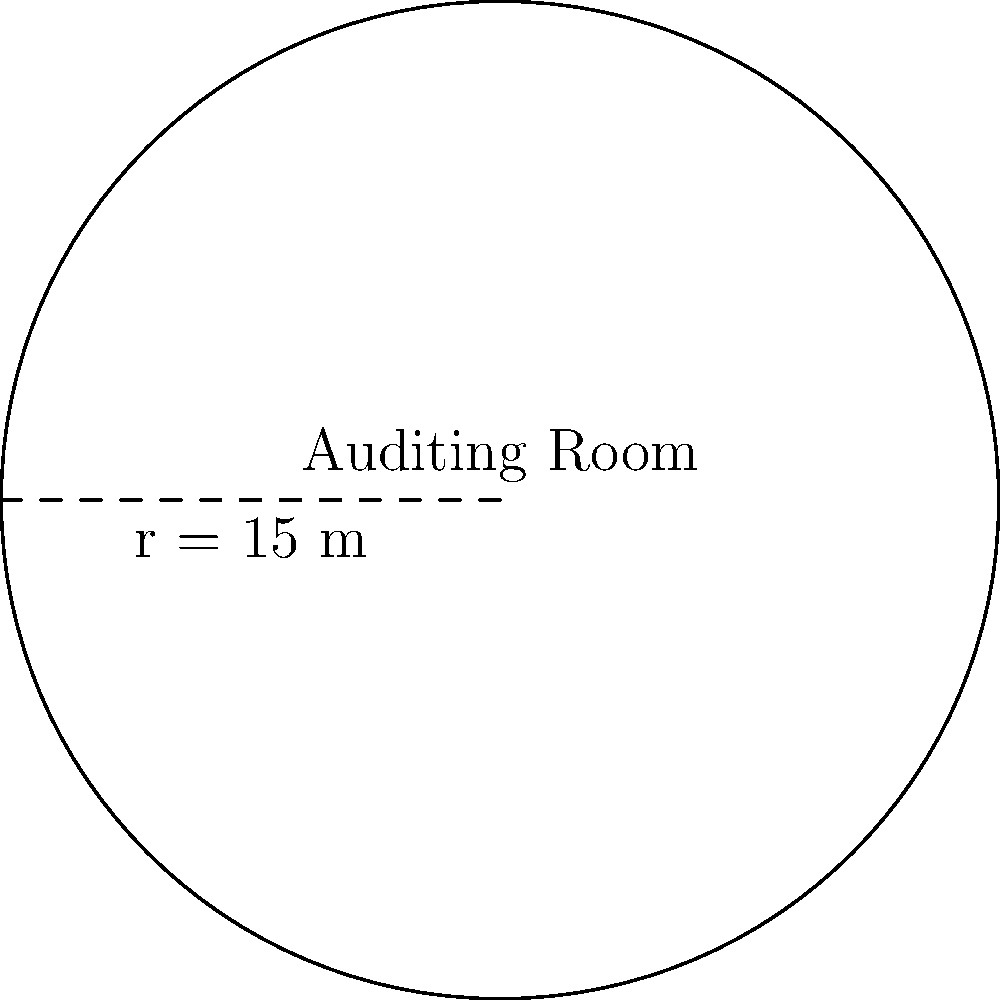In a Scientology center, a circular auditing room has a radius of 15 meters. What is the area of this room, and how does it compare to the space needed for group processing? Round your answer to the nearest whole number. To find the area of the circular auditing room, we'll use the formula for the area of a circle:

$$A = \pi r^2$$

Where:
$A$ = area
$\pi$ = pi (approximately 3.14159)
$r$ = radius

Given:
$r = 15$ meters

Step 1: Substitute the values into the formula:
$$A = \pi (15)^2$$

Step 2: Calculate the square of the radius:
$$A = \pi (225)$$

Step 3: Multiply by pi:
$$A = 706.86 \text{ m}^2$$

Step 4: Round to the nearest whole number:
$$A \approx 707 \text{ m}^2$$

This area provides ample space for individual auditing sessions, which are crucial in Scientology for personal growth and spiritual advancement. It's important to note that while this room is designed for one-on-one auditing, its size could also accommodate small group processing sessions if needed, demonstrating the versatility of the space within the Scientology center.
Answer: 707 m² 